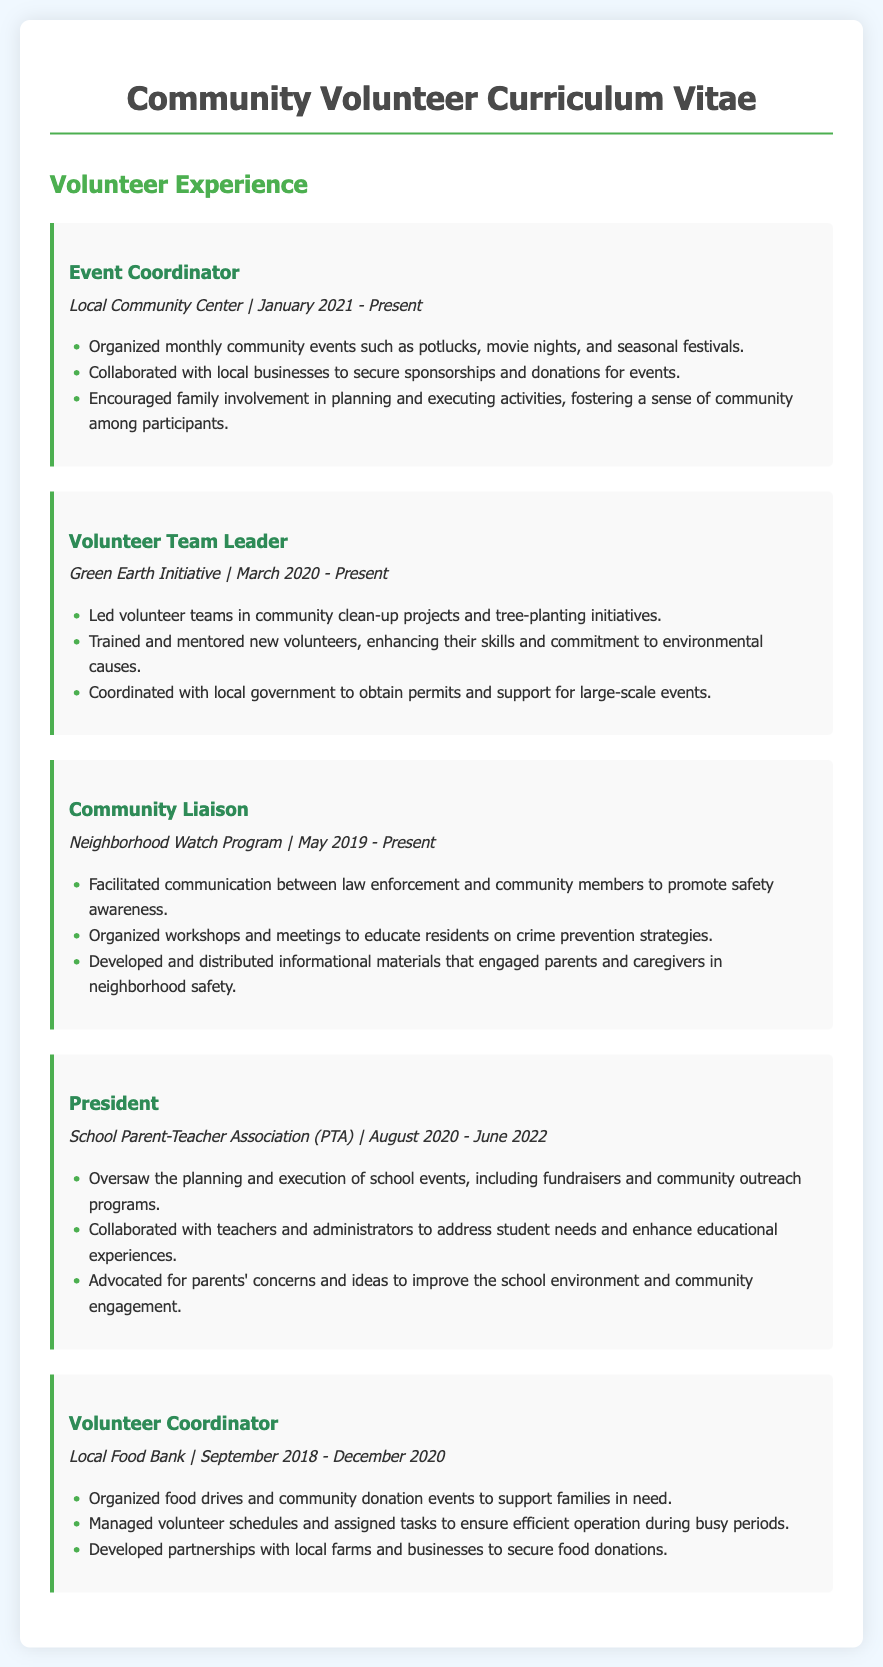What is the current role held at the Local Community Center? The document states that the current role is Event Coordinator, which is listed as being held from January 2021 to the present.
Answer: Event Coordinator When did the Volunteer Team Leader role at Green Earth Initiative start? The document indicates that the Volunteer Team Leader role began in March 2020.
Answer: March 2020 How long did the individual serve as President of the School Parent-Teacher Association? The document states that the individual served from August 2020 to June 2022, indicating a span of nearly two years.
Answer: Nearly two years What type of events did the Volunteer Coordinator for the Local Food Bank organize? The document mentions organizing food drives and community donation events as the main types of events.
Answer: Food drives and community donation events What is one of the key responsibilities of the Community Liaison in the Neighborhood Watch Program? The document notes that one responsibility is to facilitate communication between law enforcement and community members.
Answer: Facilitate communication Name the organization where the individual led clean-up projects. The document specifies the Green Earth Initiative as the organization for leading clean-up projects.
Answer: Green Earth Initiative Which community role involved collaborating with local businesses for sponsorships? The document highlights the Event Coordinator role as involving collaboration with local businesses for sponsorships.
Answer: Event Coordinator What title is held within the Neighborhood Watch Program? The document states that the individual holds the title of Community Liaison within the Neighborhood Watch Program.
Answer: Community Liaison In what year did the individual end their role at the Local Food Bank? The document states the role ended in December 2020.
Answer: December 2020 